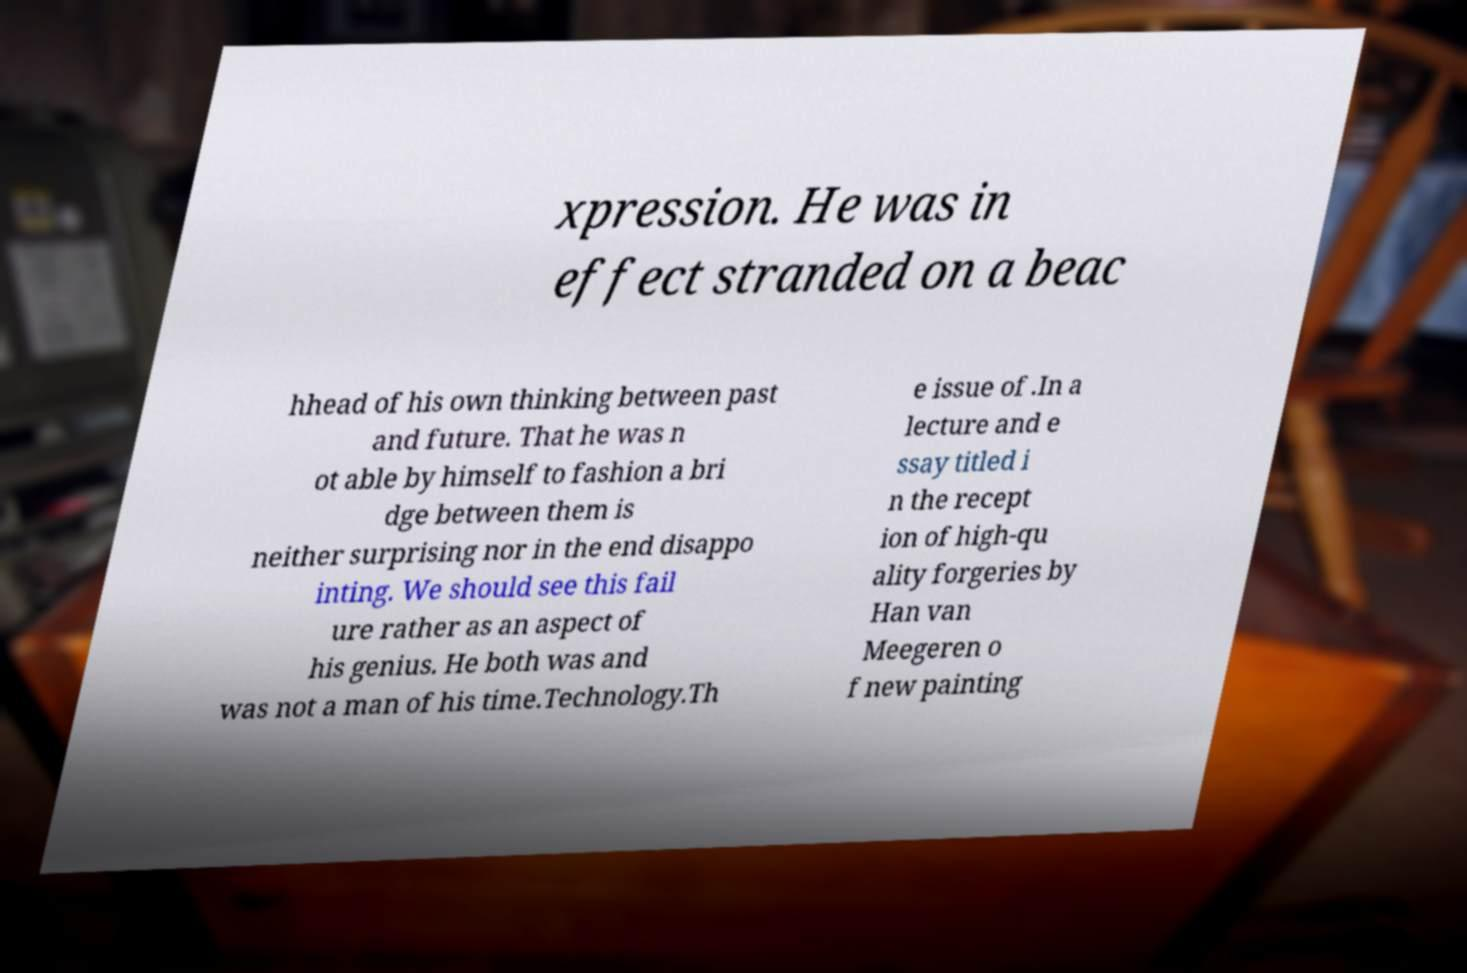Please identify and transcribe the text found in this image. xpression. He was in effect stranded on a beac hhead of his own thinking between past and future. That he was n ot able by himself to fashion a bri dge between them is neither surprising nor in the end disappo inting. We should see this fail ure rather as an aspect of his genius. He both was and was not a man of his time.Technology.Th e issue of .In a lecture and e ssay titled i n the recept ion of high-qu ality forgeries by Han van Meegeren o f new painting 